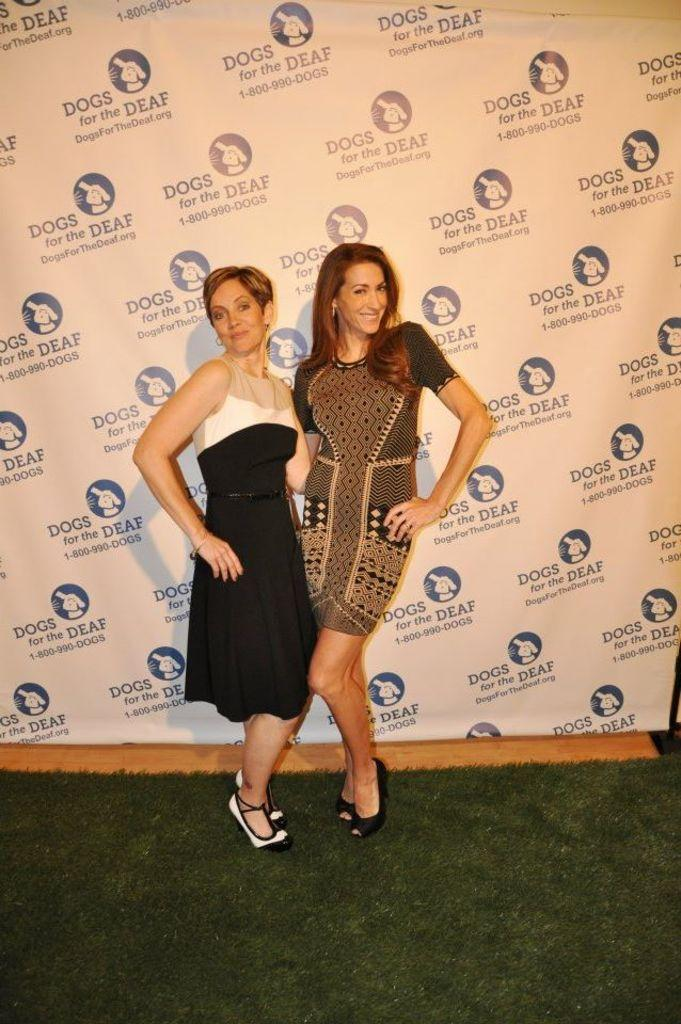How many people are the people are in the image? There are two ladies in the image. What can be seen in the background of the image? There is a banner and a wooden surface in the background of the image. What is visible at the bottom of the image? The floor is visible at the bottom of the image. What type of wool is being used by the ladies in the image? There is no wool present in the image, and the ladies' clothing or activities do not involve wool. 